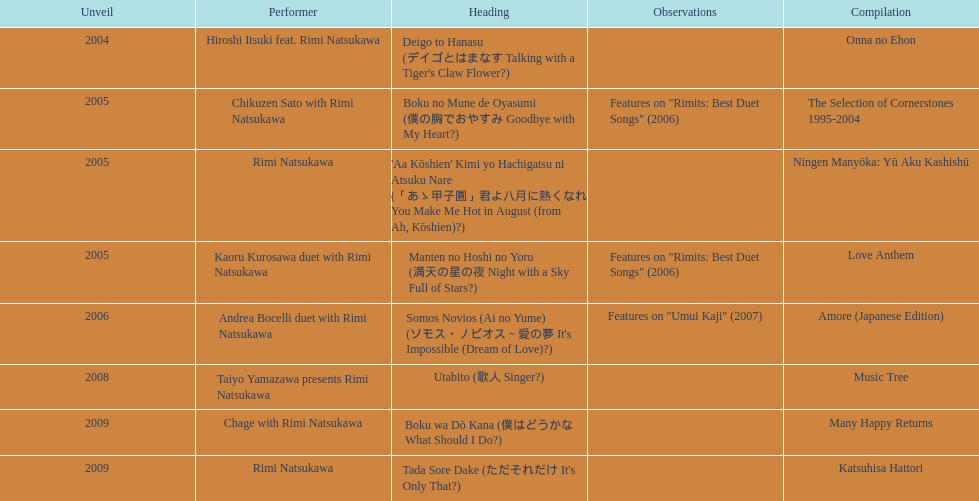What is the number of albums released with the artist rimi natsukawa? 8. 